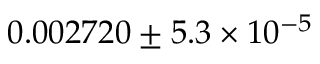<formula> <loc_0><loc_0><loc_500><loc_500>0 . 0 0 2 7 2 0 \pm 5 . 3 \times 1 0 ^ { - 5 }</formula> 